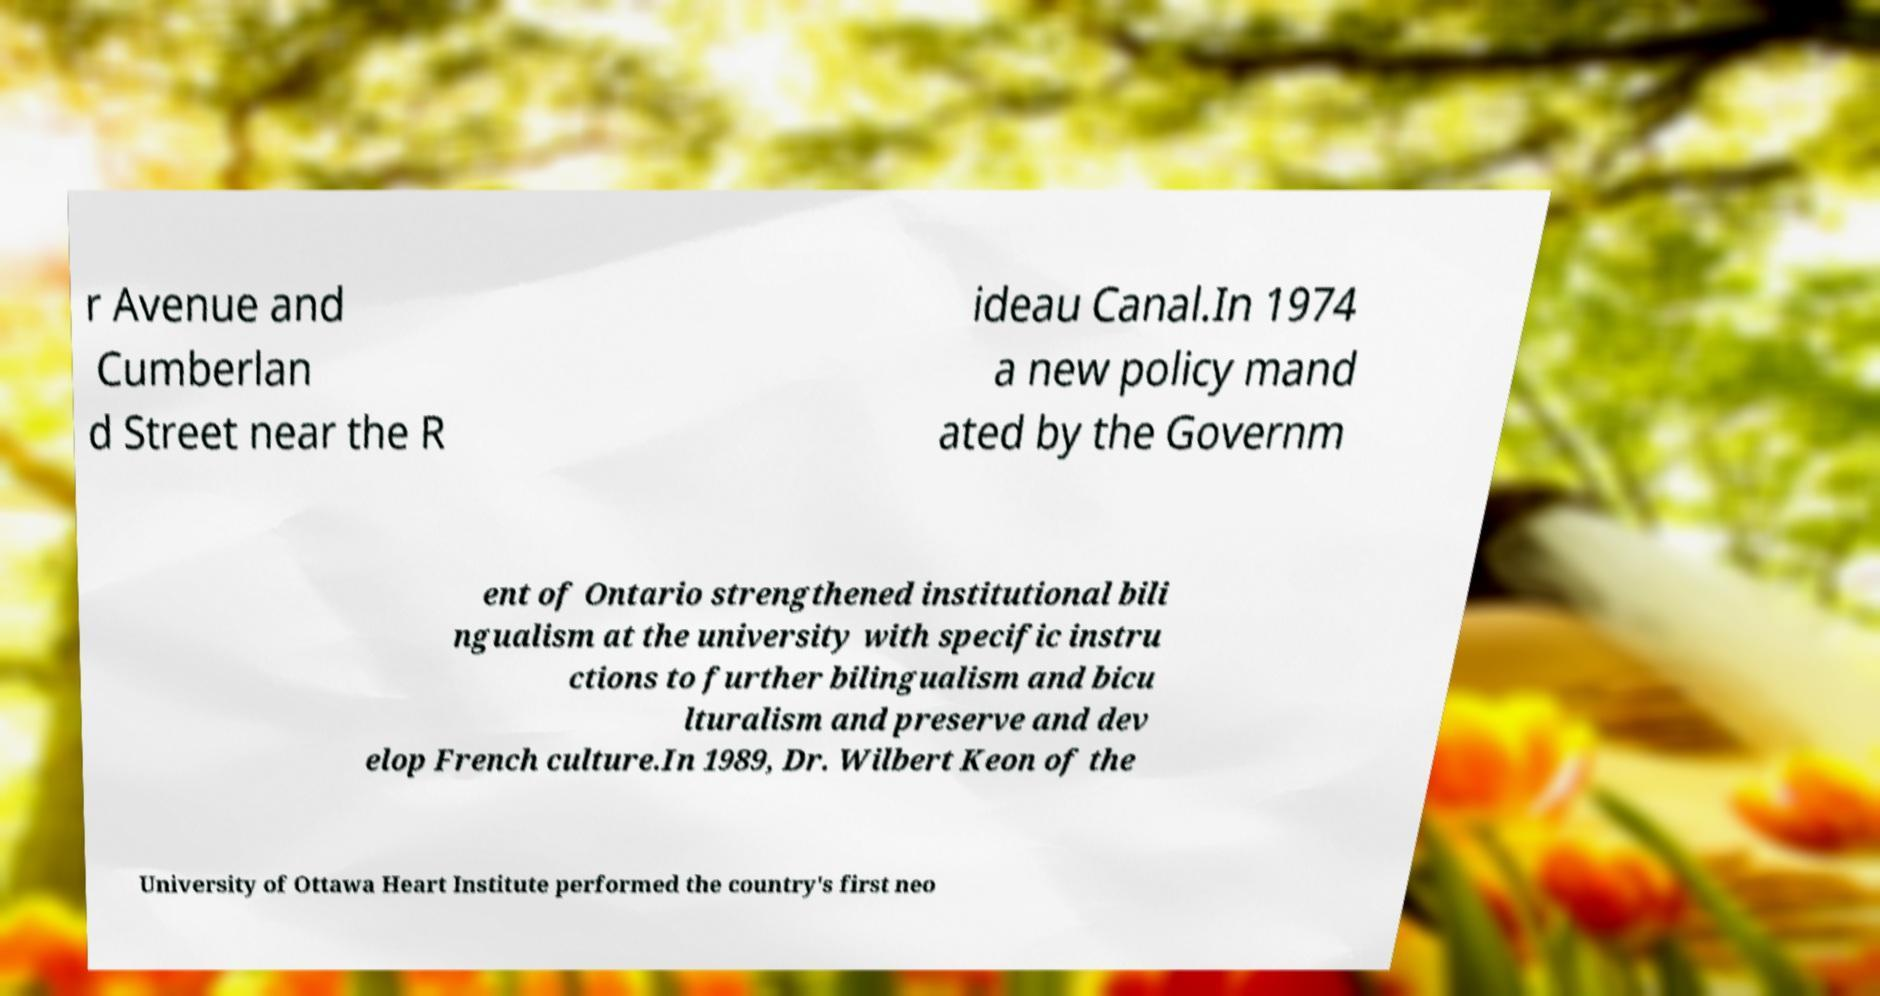What messages or text are displayed in this image? I need them in a readable, typed format. r Avenue and Cumberlan d Street near the R ideau Canal.In 1974 a new policy mand ated by the Governm ent of Ontario strengthened institutional bili ngualism at the university with specific instru ctions to further bilingualism and bicu lturalism and preserve and dev elop French culture.In 1989, Dr. Wilbert Keon of the University of Ottawa Heart Institute performed the country's first neo 